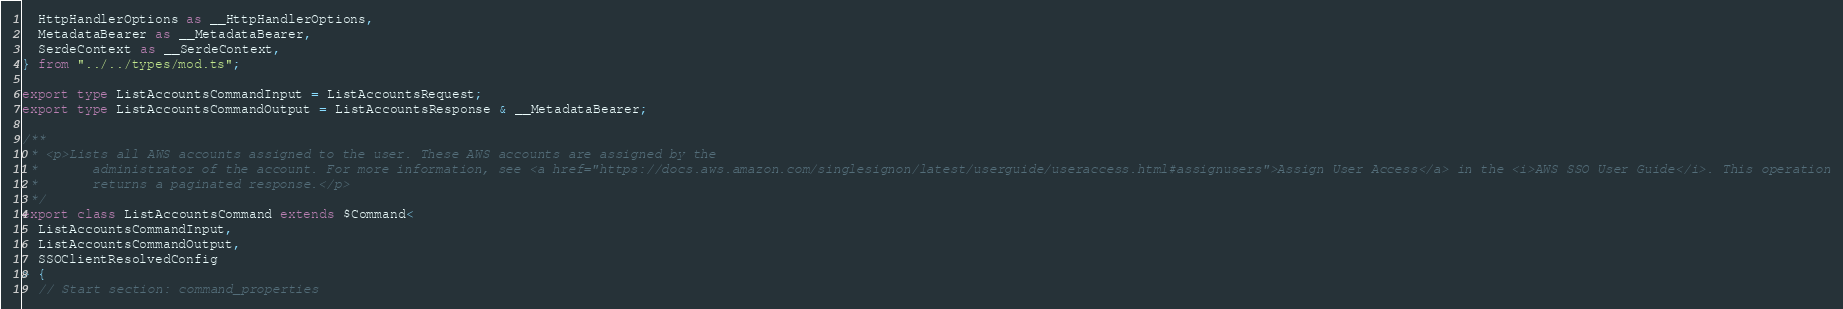Convert code to text. <code><loc_0><loc_0><loc_500><loc_500><_TypeScript_>  HttpHandlerOptions as __HttpHandlerOptions,
  MetadataBearer as __MetadataBearer,
  SerdeContext as __SerdeContext,
} from "../../types/mod.ts";

export type ListAccountsCommandInput = ListAccountsRequest;
export type ListAccountsCommandOutput = ListAccountsResponse & __MetadataBearer;

/**
 * <p>Lists all AWS accounts assigned to the user. These AWS accounts are assigned by the
 *       administrator of the account. For more information, see <a href="https://docs.aws.amazon.com/singlesignon/latest/userguide/useraccess.html#assignusers">Assign User Access</a> in the <i>AWS SSO User Guide</i>. This operation
 *       returns a paginated response.</p>
 */
export class ListAccountsCommand extends $Command<
  ListAccountsCommandInput,
  ListAccountsCommandOutput,
  SSOClientResolvedConfig
> {
  // Start section: command_properties</code> 